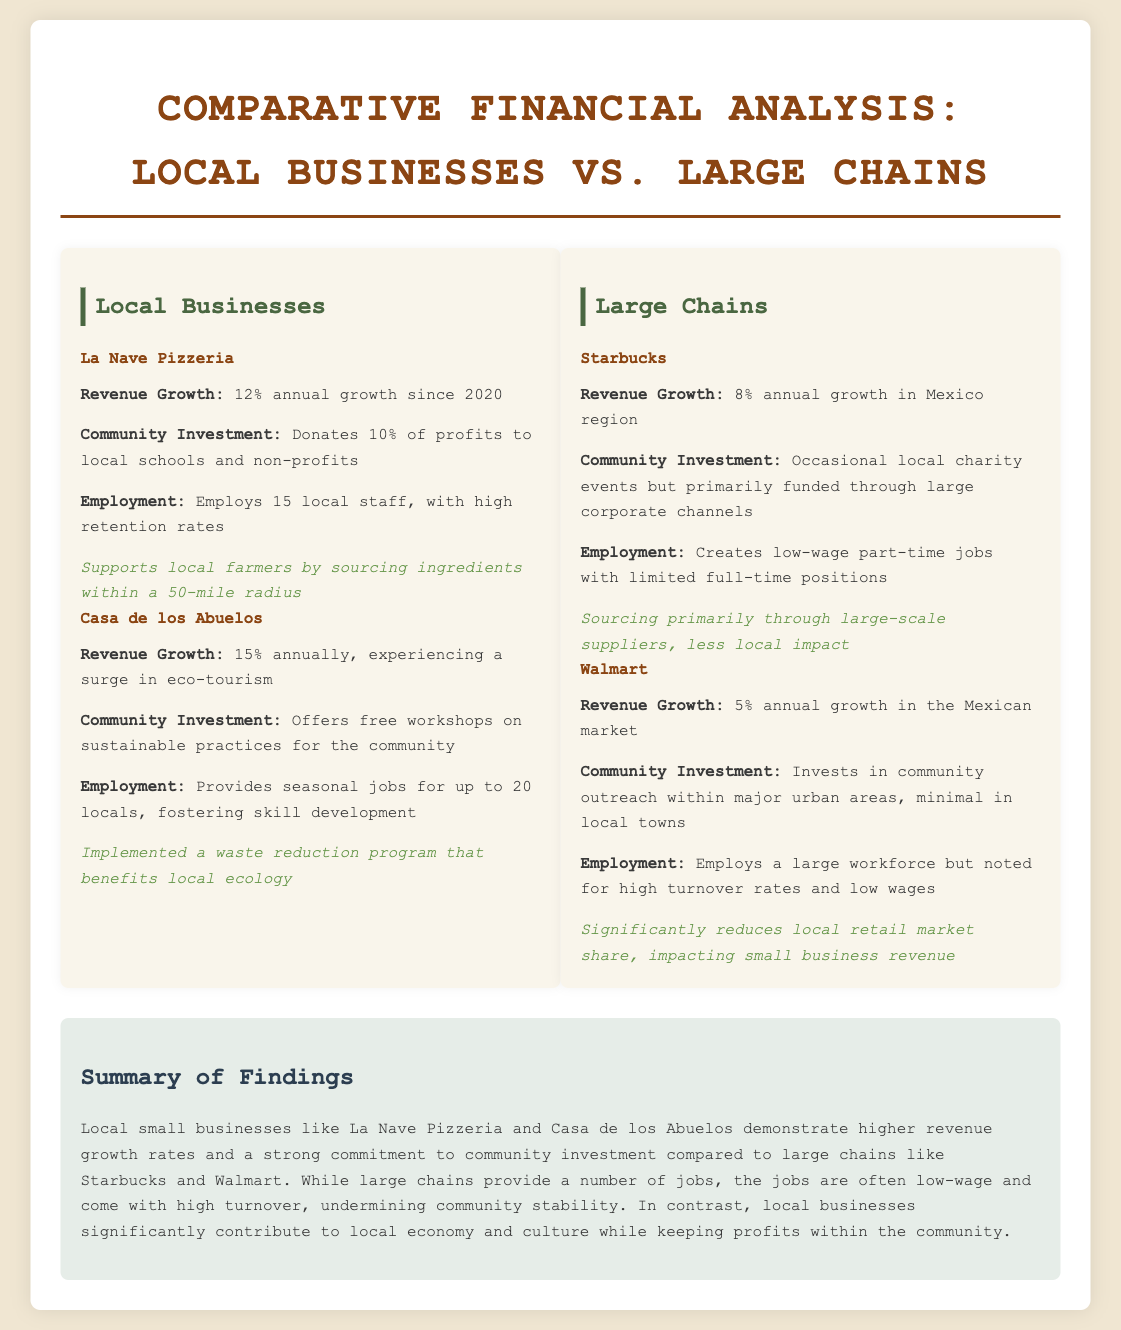What is the revenue growth rate for La Nave Pizzeria? La Nave Pizzeria has a revenue growth rate of 12% annually since 2020.
Answer: 12% annual growth What community investment does Casa de los Abuelos make? Casa de los Abuelos offers free workshops on sustainable practices for the community.
Answer: Free workshops How many local staff does Starbucks employ? The document indicates that Starbucks creates low-wage part-time jobs but does not specify a number, implying limited full-time positions.
Answer: Limited full-time positions What is the revenue growth rate for Walmart? Walmart has a revenue growth rate of 5% annually in the Mexican market.
Answer: 5% annual growth Which local business supports local farmers? La Nave Pizzeria supports local farmers by sourcing ingredients within a 50-mile radius.
Answer: La Nave Pizzeria What is a notable impact of large chains on the local market? Large chains like Walmart significantly reduce local retail market share, impacting small business revenue.
Answer: Reduces local retail market share What is the employment trend for Casa de los Abuelos? Casa de los Abuelos provides seasonal jobs for up to 20 locals, fostering skill development.
Answer: Seasonal jobs for up to 20 locals What is the main reason for high turnover at large chains? High turnover rates and low wages are noted as issues with employment at large chains.
Answer: High turnover rates and low wages Which local business demonstrates higher revenue growth rates compared to large chains? Local small businesses like La Nave Pizzeria and Casa de los Abuelos demonstrate higher revenue growth rates.
Answer: La Nave Pizzeria and Casa de los Abuelos 